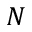<formula> <loc_0><loc_0><loc_500><loc_500>N</formula> 